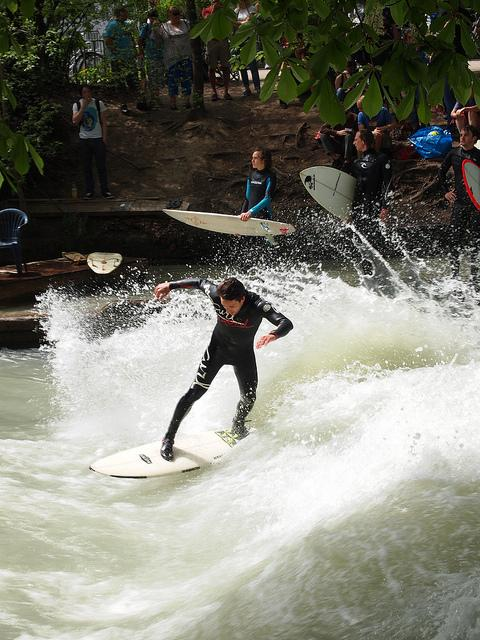Why is he standing like that? balance 